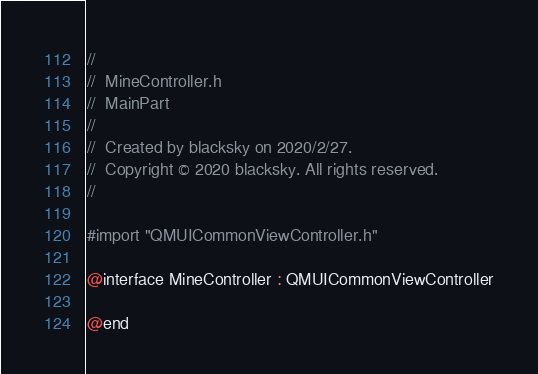<code> <loc_0><loc_0><loc_500><loc_500><_C_>//
//  MineController.h
//  MainPart
//
//  Created by blacksky on 2020/2/27.
//  Copyright © 2020 blacksky. All rights reserved.
//

#import "QMUICommonViewController.h"

@interface MineController : QMUICommonViewController

@end
</code> 